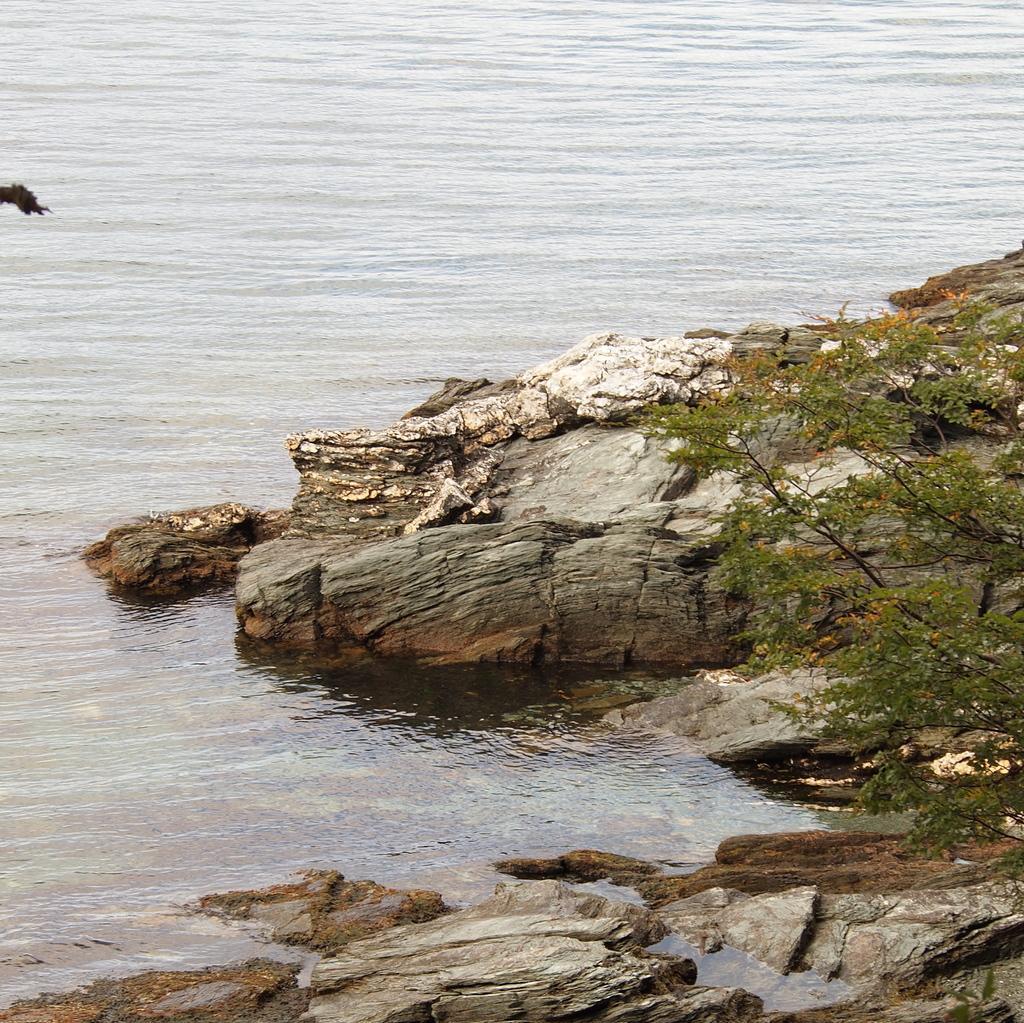Can you describe this image briefly? In this image we can see some trees, stones and in the background of the image there is water. 